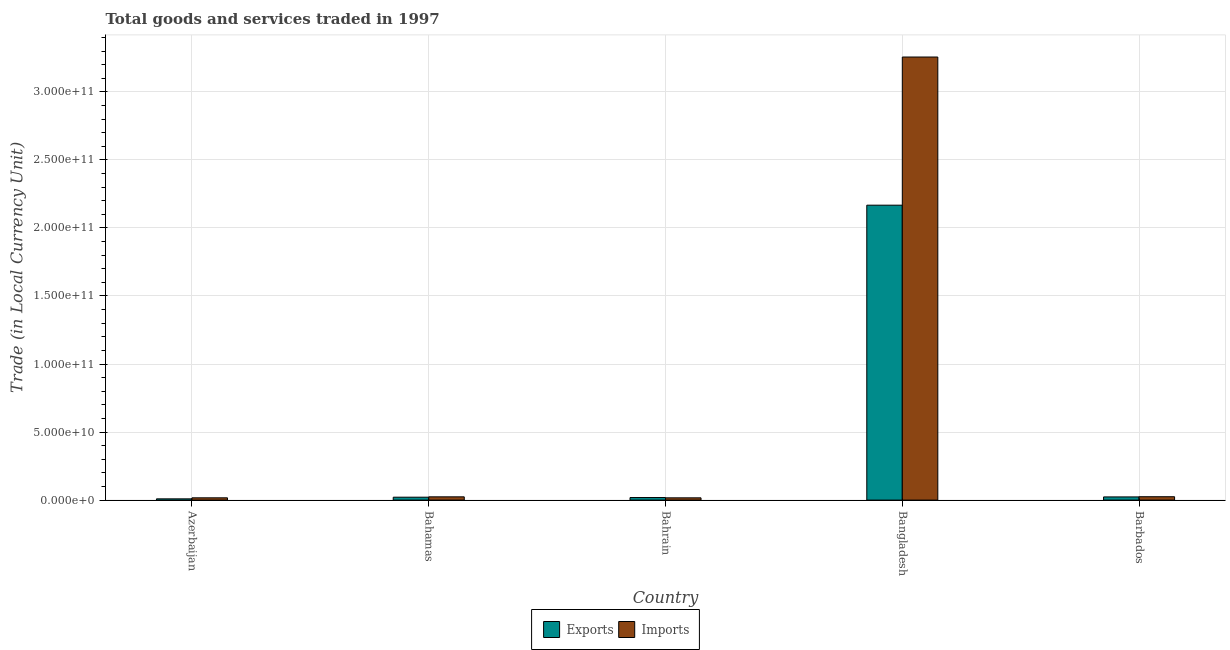How many different coloured bars are there?
Make the answer very short. 2. Are the number of bars per tick equal to the number of legend labels?
Your answer should be very brief. Yes. How many bars are there on the 4th tick from the right?
Offer a very short reply. 2. What is the label of the 3rd group of bars from the left?
Your answer should be very brief. Bahrain. In how many cases, is the number of bars for a given country not equal to the number of legend labels?
Your response must be concise. 0. What is the export of goods and services in Bahamas?
Ensure brevity in your answer.  2.13e+09. Across all countries, what is the maximum imports of goods and services?
Make the answer very short. 3.26e+11. Across all countries, what is the minimum export of goods and services?
Provide a short and direct response. 9.17e+08. In which country was the imports of goods and services minimum?
Your response must be concise. Bahrain. What is the total imports of goods and services in the graph?
Offer a terse response. 3.34e+11. What is the difference between the imports of goods and services in Azerbaijan and that in Bangladesh?
Offer a terse response. -3.24e+11. What is the difference between the imports of goods and services in Bahamas and the export of goods and services in Barbados?
Make the answer very short. 5.73e+07. What is the average imports of goods and services per country?
Provide a short and direct response. 6.68e+1. What is the difference between the export of goods and services and imports of goods and services in Bahamas?
Provide a short and direct response. -2.61e+08. What is the ratio of the export of goods and services in Azerbaijan to that in Bahamas?
Give a very brief answer. 0.43. Is the imports of goods and services in Azerbaijan less than that in Bahrain?
Make the answer very short. No. What is the difference between the highest and the second highest export of goods and services?
Your answer should be compact. 2.14e+11. What is the difference between the highest and the lowest imports of goods and services?
Your answer should be very brief. 3.24e+11. What does the 2nd bar from the left in Bahamas represents?
Keep it short and to the point. Imports. What does the 2nd bar from the right in Bangladesh represents?
Keep it short and to the point. Exports. How many bars are there?
Ensure brevity in your answer.  10. Are all the bars in the graph horizontal?
Offer a very short reply. No. What is the difference between two consecutive major ticks on the Y-axis?
Give a very brief answer. 5.00e+1. Does the graph contain grids?
Your answer should be compact. Yes. Where does the legend appear in the graph?
Provide a succinct answer. Bottom center. What is the title of the graph?
Make the answer very short. Total goods and services traded in 1997. What is the label or title of the Y-axis?
Your response must be concise. Trade (in Local Currency Unit). What is the Trade (in Local Currency Unit) in Exports in Azerbaijan?
Give a very brief answer. 9.17e+08. What is the Trade (in Local Currency Unit) in Imports in Azerbaijan?
Your answer should be compact. 1.67e+09. What is the Trade (in Local Currency Unit) in Exports in Bahamas?
Make the answer very short. 2.13e+09. What is the Trade (in Local Currency Unit) in Imports in Bahamas?
Make the answer very short. 2.39e+09. What is the Trade (in Local Currency Unit) in Exports in Bahrain?
Your answer should be compact. 1.89e+09. What is the Trade (in Local Currency Unit) in Imports in Bahrain?
Offer a terse response. 1.66e+09. What is the Trade (in Local Currency Unit) in Exports in Bangladesh?
Ensure brevity in your answer.  2.17e+11. What is the Trade (in Local Currency Unit) in Imports in Bangladesh?
Give a very brief answer. 3.26e+11. What is the Trade (in Local Currency Unit) in Exports in Barbados?
Keep it short and to the point. 2.34e+09. What is the Trade (in Local Currency Unit) in Imports in Barbados?
Make the answer very short. 2.48e+09. Across all countries, what is the maximum Trade (in Local Currency Unit) in Exports?
Your response must be concise. 2.17e+11. Across all countries, what is the maximum Trade (in Local Currency Unit) in Imports?
Offer a very short reply. 3.26e+11. Across all countries, what is the minimum Trade (in Local Currency Unit) of Exports?
Provide a succinct answer. 9.17e+08. Across all countries, what is the minimum Trade (in Local Currency Unit) in Imports?
Offer a very short reply. 1.66e+09. What is the total Trade (in Local Currency Unit) of Exports in the graph?
Offer a very short reply. 2.24e+11. What is the total Trade (in Local Currency Unit) in Imports in the graph?
Offer a very short reply. 3.34e+11. What is the difference between the Trade (in Local Currency Unit) of Exports in Azerbaijan and that in Bahamas?
Offer a terse response. -1.22e+09. What is the difference between the Trade (in Local Currency Unit) of Imports in Azerbaijan and that in Bahamas?
Give a very brief answer. -7.20e+08. What is the difference between the Trade (in Local Currency Unit) of Exports in Azerbaijan and that in Bahrain?
Your answer should be very brief. -9.71e+08. What is the difference between the Trade (in Local Currency Unit) of Imports in Azerbaijan and that in Bahrain?
Your answer should be compact. 1.54e+07. What is the difference between the Trade (in Local Currency Unit) of Exports in Azerbaijan and that in Bangladesh?
Your answer should be very brief. -2.16e+11. What is the difference between the Trade (in Local Currency Unit) of Imports in Azerbaijan and that in Bangladesh?
Offer a terse response. -3.24e+11. What is the difference between the Trade (in Local Currency Unit) in Exports in Azerbaijan and that in Barbados?
Your answer should be very brief. -1.42e+09. What is the difference between the Trade (in Local Currency Unit) of Imports in Azerbaijan and that in Barbados?
Your response must be concise. -8.01e+08. What is the difference between the Trade (in Local Currency Unit) in Exports in Bahamas and that in Bahrain?
Keep it short and to the point. 2.45e+08. What is the difference between the Trade (in Local Currency Unit) of Imports in Bahamas and that in Bahrain?
Provide a short and direct response. 7.35e+08. What is the difference between the Trade (in Local Currency Unit) in Exports in Bahamas and that in Bangladesh?
Make the answer very short. -2.15e+11. What is the difference between the Trade (in Local Currency Unit) of Imports in Bahamas and that in Bangladesh?
Offer a very short reply. -3.23e+11. What is the difference between the Trade (in Local Currency Unit) in Exports in Bahamas and that in Barbados?
Your answer should be very brief. -2.04e+08. What is the difference between the Trade (in Local Currency Unit) of Imports in Bahamas and that in Barbados?
Your answer should be very brief. -8.17e+07. What is the difference between the Trade (in Local Currency Unit) in Exports in Bahrain and that in Bangladesh?
Your answer should be compact. -2.15e+11. What is the difference between the Trade (in Local Currency Unit) in Imports in Bahrain and that in Bangladesh?
Keep it short and to the point. -3.24e+11. What is the difference between the Trade (in Local Currency Unit) in Exports in Bahrain and that in Barbados?
Provide a succinct answer. -4.49e+08. What is the difference between the Trade (in Local Currency Unit) of Imports in Bahrain and that in Barbados?
Keep it short and to the point. -8.17e+08. What is the difference between the Trade (in Local Currency Unit) of Exports in Bangladesh and that in Barbados?
Offer a terse response. 2.14e+11. What is the difference between the Trade (in Local Currency Unit) in Imports in Bangladesh and that in Barbados?
Give a very brief answer. 3.23e+11. What is the difference between the Trade (in Local Currency Unit) of Exports in Azerbaijan and the Trade (in Local Currency Unit) of Imports in Bahamas?
Your answer should be very brief. -1.48e+09. What is the difference between the Trade (in Local Currency Unit) in Exports in Azerbaijan and the Trade (in Local Currency Unit) in Imports in Bahrain?
Your answer should be very brief. -7.43e+08. What is the difference between the Trade (in Local Currency Unit) of Exports in Azerbaijan and the Trade (in Local Currency Unit) of Imports in Bangladesh?
Your answer should be very brief. -3.25e+11. What is the difference between the Trade (in Local Currency Unit) in Exports in Azerbaijan and the Trade (in Local Currency Unit) in Imports in Barbados?
Your response must be concise. -1.56e+09. What is the difference between the Trade (in Local Currency Unit) in Exports in Bahamas and the Trade (in Local Currency Unit) in Imports in Bahrain?
Your answer should be very brief. 4.74e+08. What is the difference between the Trade (in Local Currency Unit) in Exports in Bahamas and the Trade (in Local Currency Unit) in Imports in Bangladesh?
Provide a succinct answer. -3.23e+11. What is the difference between the Trade (in Local Currency Unit) in Exports in Bahamas and the Trade (in Local Currency Unit) in Imports in Barbados?
Your answer should be compact. -3.43e+08. What is the difference between the Trade (in Local Currency Unit) of Exports in Bahrain and the Trade (in Local Currency Unit) of Imports in Bangladesh?
Offer a very short reply. -3.24e+11. What is the difference between the Trade (in Local Currency Unit) of Exports in Bahrain and the Trade (in Local Currency Unit) of Imports in Barbados?
Keep it short and to the point. -5.88e+08. What is the difference between the Trade (in Local Currency Unit) of Exports in Bangladesh and the Trade (in Local Currency Unit) of Imports in Barbados?
Give a very brief answer. 2.14e+11. What is the average Trade (in Local Currency Unit) in Exports per country?
Offer a terse response. 4.48e+1. What is the average Trade (in Local Currency Unit) of Imports per country?
Keep it short and to the point. 6.68e+1. What is the difference between the Trade (in Local Currency Unit) in Exports and Trade (in Local Currency Unit) in Imports in Azerbaijan?
Keep it short and to the point. -7.58e+08. What is the difference between the Trade (in Local Currency Unit) of Exports and Trade (in Local Currency Unit) of Imports in Bahamas?
Keep it short and to the point. -2.61e+08. What is the difference between the Trade (in Local Currency Unit) of Exports and Trade (in Local Currency Unit) of Imports in Bahrain?
Give a very brief answer. 2.29e+08. What is the difference between the Trade (in Local Currency Unit) of Exports and Trade (in Local Currency Unit) of Imports in Bangladesh?
Provide a short and direct response. -1.09e+11. What is the difference between the Trade (in Local Currency Unit) in Exports and Trade (in Local Currency Unit) in Imports in Barbados?
Your answer should be very brief. -1.39e+08. What is the ratio of the Trade (in Local Currency Unit) of Exports in Azerbaijan to that in Bahamas?
Make the answer very short. 0.43. What is the ratio of the Trade (in Local Currency Unit) in Imports in Azerbaijan to that in Bahamas?
Your answer should be compact. 0.7. What is the ratio of the Trade (in Local Currency Unit) in Exports in Azerbaijan to that in Bahrain?
Provide a succinct answer. 0.49. What is the ratio of the Trade (in Local Currency Unit) of Imports in Azerbaijan to that in Bahrain?
Give a very brief answer. 1.01. What is the ratio of the Trade (in Local Currency Unit) of Exports in Azerbaijan to that in Bangladesh?
Provide a short and direct response. 0. What is the ratio of the Trade (in Local Currency Unit) of Imports in Azerbaijan to that in Bangladesh?
Provide a succinct answer. 0.01. What is the ratio of the Trade (in Local Currency Unit) of Exports in Azerbaijan to that in Barbados?
Keep it short and to the point. 0.39. What is the ratio of the Trade (in Local Currency Unit) in Imports in Azerbaijan to that in Barbados?
Ensure brevity in your answer.  0.68. What is the ratio of the Trade (in Local Currency Unit) in Exports in Bahamas to that in Bahrain?
Make the answer very short. 1.13. What is the ratio of the Trade (in Local Currency Unit) of Imports in Bahamas to that in Bahrain?
Your answer should be compact. 1.44. What is the ratio of the Trade (in Local Currency Unit) in Exports in Bahamas to that in Bangladesh?
Your answer should be very brief. 0.01. What is the ratio of the Trade (in Local Currency Unit) of Imports in Bahamas to that in Bangladesh?
Provide a short and direct response. 0.01. What is the ratio of the Trade (in Local Currency Unit) in Exports in Bahamas to that in Barbados?
Ensure brevity in your answer.  0.91. What is the ratio of the Trade (in Local Currency Unit) of Exports in Bahrain to that in Bangladesh?
Ensure brevity in your answer.  0.01. What is the ratio of the Trade (in Local Currency Unit) in Imports in Bahrain to that in Bangladesh?
Make the answer very short. 0.01. What is the ratio of the Trade (in Local Currency Unit) in Exports in Bahrain to that in Barbados?
Give a very brief answer. 0.81. What is the ratio of the Trade (in Local Currency Unit) of Imports in Bahrain to that in Barbados?
Your answer should be compact. 0.67. What is the ratio of the Trade (in Local Currency Unit) in Exports in Bangladesh to that in Barbados?
Provide a short and direct response. 92.74. What is the ratio of the Trade (in Local Currency Unit) of Imports in Bangladesh to that in Barbados?
Provide a short and direct response. 131.5. What is the difference between the highest and the second highest Trade (in Local Currency Unit) of Exports?
Provide a short and direct response. 2.14e+11. What is the difference between the highest and the second highest Trade (in Local Currency Unit) of Imports?
Your response must be concise. 3.23e+11. What is the difference between the highest and the lowest Trade (in Local Currency Unit) in Exports?
Provide a succinct answer. 2.16e+11. What is the difference between the highest and the lowest Trade (in Local Currency Unit) in Imports?
Ensure brevity in your answer.  3.24e+11. 